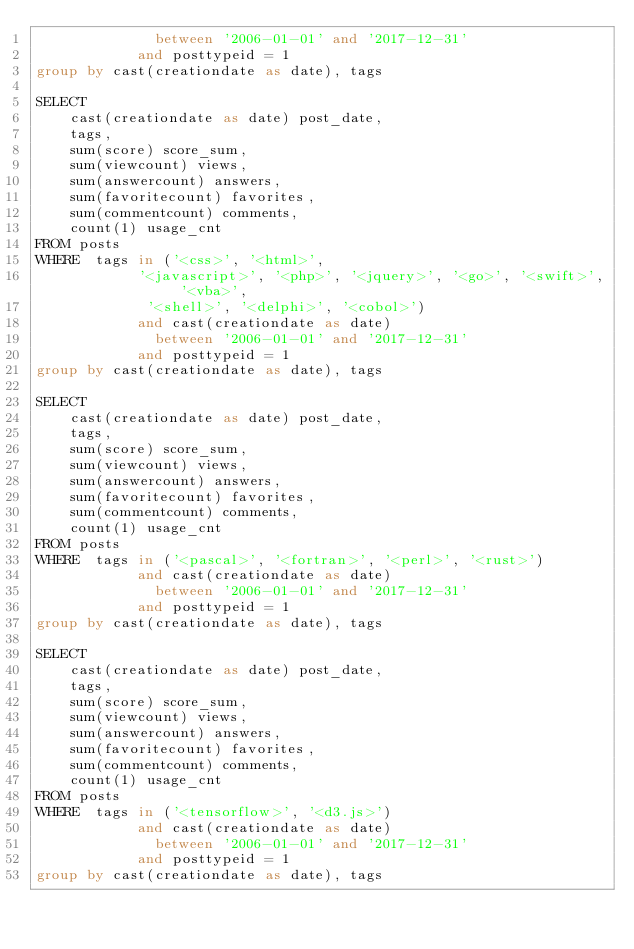<code> <loc_0><loc_0><loc_500><loc_500><_SQL_>              between '2006-01-01' and '2017-12-31'
            and posttypeid = 1
group by cast(creationdate as date), tags

SELECT
    cast(creationdate as date) post_date,
    tags,
    sum(score) score_sum,
    sum(viewcount) views,
    sum(answercount) answers,
    sum(favoritecount) favorites,
    sum(commentcount) comments,
    count(1) usage_cnt
FROM posts
WHERE  tags in ('<css>', '<html>',
			'<javascript>', '<php>', '<jquery>', '<go>', '<swift>', '<vba>',
             '<shell>', '<delphi>', '<cobol>')
			and cast(creationdate as date)
              between '2006-01-01' and '2017-12-31'
            and posttypeid = 1
group by cast(creationdate as date), tags

SELECT
    cast(creationdate as date) post_date,
    tags,
    sum(score) score_sum,
    sum(viewcount) views,
    sum(answercount) answers,
    sum(favoritecount) favorites,
    sum(commentcount) comments,
    count(1) usage_cnt
FROM posts
WHERE  tags in ('<pascal>', '<fortran>', '<perl>', '<rust>')
			and cast(creationdate as date)
              between '2006-01-01' and '2017-12-31'
            and posttypeid = 1
group by cast(creationdate as date), tags

SELECT
    cast(creationdate as date) post_date,
    tags,
    sum(score) score_sum,
    sum(viewcount) views,
    sum(answercount) answers,
    sum(favoritecount) favorites,
    sum(commentcount) comments,
    count(1) usage_cnt
FROM posts
WHERE  tags in ('<tensorflow>', '<d3.js>')
			and cast(creationdate as date)
              between '2006-01-01' and '2017-12-31'
            and posttypeid = 1
group by cast(creationdate as date), tags
</code> 